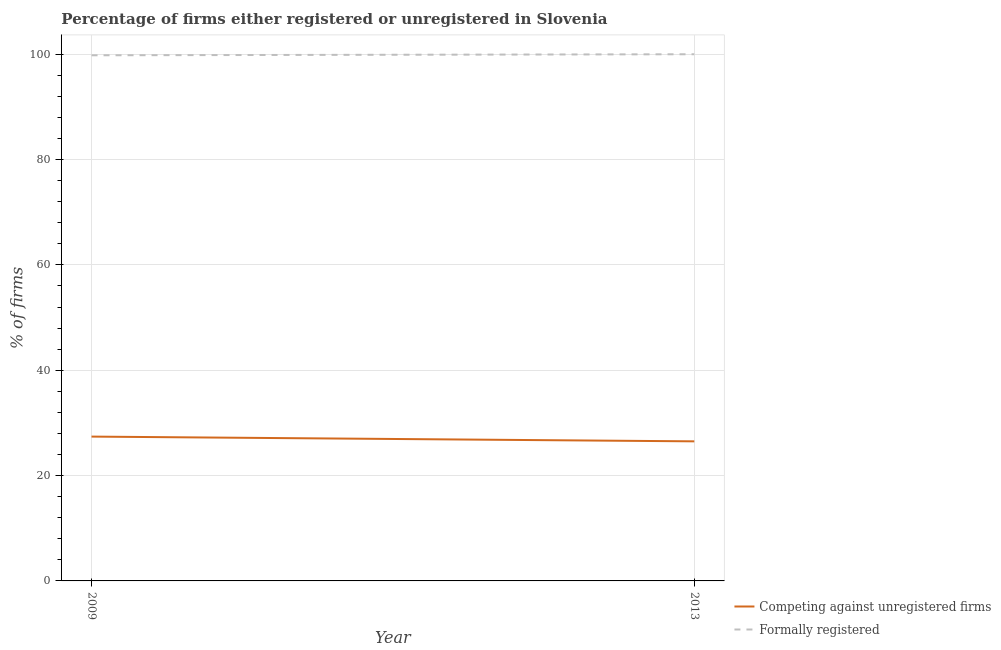How many different coloured lines are there?
Offer a terse response. 2. Does the line corresponding to percentage of formally registered firms intersect with the line corresponding to percentage of registered firms?
Make the answer very short. No. Is the number of lines equal to the number of legend labels?
Offer a terse response. Yes. What is the percentage of formally registered firms in 2009?
Offer a very short reply. 99.8. Across all years, what is the maximum percentage of registered firms?
Keep it short and to the point. 27.4. Across all years, what is the minimum percentage of registered firms?
Your answer should be compact. 26.5. In which year was the percentage of registered firms maximum?
Offer a terse response. 2009. In which year was the percentage of registered firms minimum?
Your answer should be very brief. 2013. What is the total percentage of formally registered firms in the graph?
Make the answer very short. 199.8. What is the difference between the percentage of registered firms in 2009 and that in 2013?
Your answer should be very brief. 0.9. What is the difference between the percentage of formally registered firms in 2009 and the percentage of registered firms in 2013?
Give a very brief answer. 73.3. What is the average percentage of registered firms per year?
Ensure brevity in your answer.  26.95. In the year 2009, what is the difference between the percentage of formally registered firms and percentage of registered firms?
Your answer should be very brief. 72.4. What is the ratio of the percentage of formally registered firms in 2009 to that in 2013?
Make the answer very short. 1. Does the percentage of formally registered firms monotonically increase over the years?
Keep it short and to the point. Yes. Is the percentage of formally registered firms strictly greater than the percentage of registered firms over the years?
Give a very brief answer. Yes. Is the percentage of registered firms strictly less than the percentage of formally registered firms over the years?
Make the answer very short. Yes. How are the legend labels stacked?
Your response must be concise. Vertical. What is the title of the graph?
Offer a terse response. Percentage of firms either registered or unregistered in Slovenia. Does "Broad money growth" appear as one of the legend labels in the graph?
Offer a terse response. No. What is the label or title of the X-axis?
Keep it short and to the point. Year. What is the label or title of the Y-axis?
Your answer should be very brief. % of firms. What is the % of firms of Competing against unregistered firms in 2009?
Provide a short and direct response. 27.4. What is the % of firms of Formally registered in 2009?
Provide a succinct answer. 99.8. What is the % of firms in Competing against unregistered firms in 2013?
Give a very brief answer. 26.5. What is the % of firms in Formally registered in 2013?
Make the answer very short. 100. Across all years, what is the maximum % of firms of Competing against unregistered firms?
Give a very brief answer. 27.4. Across all years, what is the minimum % of firms of Formally registered?
Offer a very short reply. 99.8. What is the total % of firms of Competing against unregistered firms in the graph?
Your response must be concise. 53.9. What is the total % of firms in Formally registered in the graph?
Your answer should be compact. 199.8. What is the difference between the % of firms of Competing against unregistered firms in 2009 and that in 2013?
Your response must be concise. 0.9. What is the difference between the % of firms of Competing against unregistered firms in 2009 and the % of firms of Formally registered in 2013?
Give a very brief answer. -72.6. What is the average % of firms of Competing against unregistered firms per year?
Make the answer very short. 26.95. What is the average % of firms of Formally registered per year?
Your response must be concise. 99.9. In the year 2009, what is the difference between the % of firms in Competing against unregistered firms and % of firms in Formally registered?
Your response must be concise. -72.4. In the year 2013, what is the difference between the % of firms in Competing against unregistered firms and % of firms in Formally registered?
Provide a succinct answer. -73.5. What is the ratio of the % of firms in Competing against unregistered firms in 2009 to that in 2013?
Provide a short and direct response. 1.03. What is the ratio of the % of firms in Formally registered in 2009 to that in 2013?
Make the answer very short. 1. What is the difference between the highest and the lowest % of firms in Competing against unregistered firms?
Make the answer very short. 0.9. What is the difference between the highest and the lowest % of firms of Formally registered?
Your response must be concise. 0.2. 